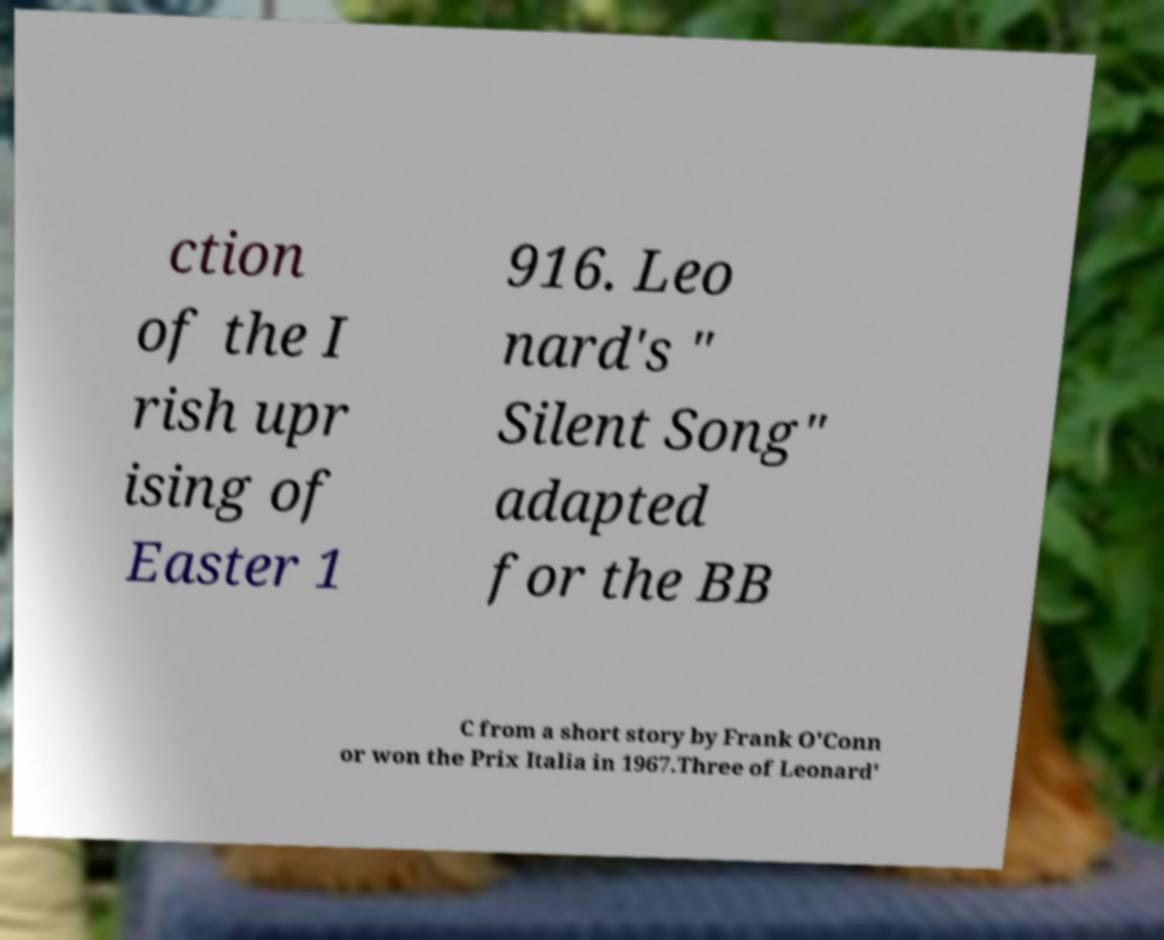Can you accurately transcribe the text from the provided image for me? ction of the I rish upr ising of Easter 1 916. Leo nard's " Silent Song" adapted for the BB C from a short story by Frank O'Conn or won the Prix Italia in 1967.Three of Leonard' 